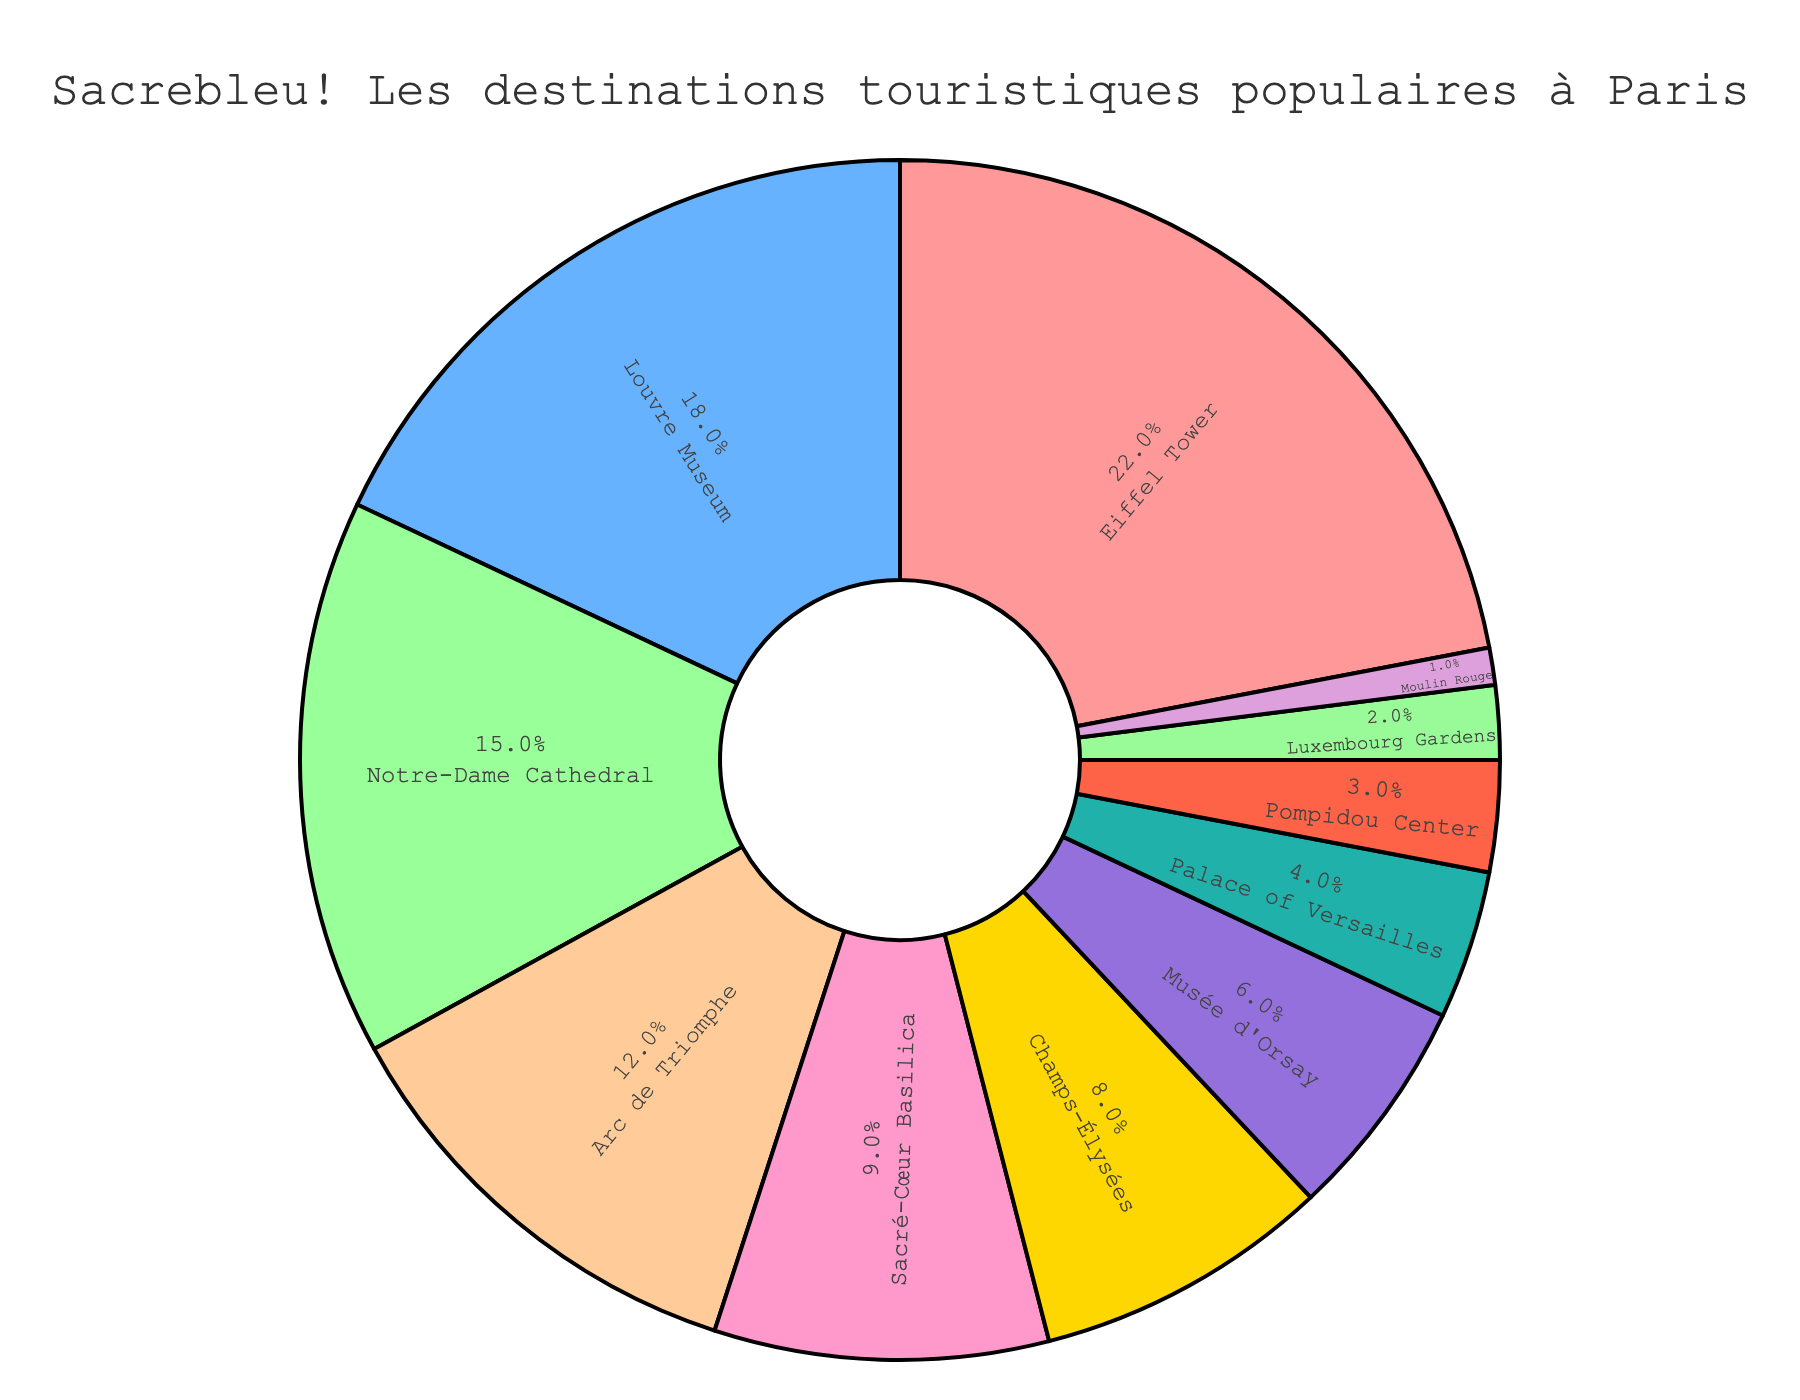Which tourist destination in Paris has the highest percentage of cab rides? The figure shows the breakdown of popular tourist destinations in Paris by percentage of cab rides. The Eiffel Tower has the largest segment in the pie chart, indicating it has the highest percentage.
Answer: Eiffel Tower What is the combined percentage of cab rides to the Louvre Museum and Notre-Dame Cathedral? According to the pie chart, the Louvre Museum accounts for 18% of cab rides, and the Notre-Dame Cathedral accounts for 15%. Adding these together gives us a combined percentage. 18% + 15% = 33%
Answer: 33% Which destination has a higher percentage of cab rides, Sacré-Cœur Basilica or Arc de Triomphe? By observing the pie chart, Sacré-Cœur Basilica has 9%, while Arc de Triomphe has 12%. Comparing these percentages, Arc de Triomphe has a higher percentage.
Answer: Arc de Triomphe What is the difference in percentage between the destination with the lowest cab rides and the destination with the highest cab rides? The destination with the highest percentage of cab rides is the Eiffel Tower at 22%, and the destination with the lowest percentage is Moulin Rouge at 1%. The difference is calculated by subtracting the smallest percentage from the largest percentage. 22% - 1% = 21%
Answer: 21% What color represents the Champs-Élysées in the pie chart? By observing the pie chart legend, each destination is represented by different colors. The Champs-Élysées is represented by the color that matches its segment in the pie chart. The color of the Champs-Élysées segment is yellow.
Answer: yellow How many more percentage points are there for Musée d'Orsay compared to Luxembourg Gardens? According to the pie chart, Musée d'Orsay has a percentage of 6% and Luxembourg Gardens has 2%. Subtract the percentage of Luxembourg Gardens from Musée d'Orsay to find the difference: 6% - 2% = 4%
Answer: 4% What is the sum of percentages for the top three tourist destinations in Paris by cab rides? The top three destinations by percentage are the Eiffel Tower, Louvre Museum, and Notre-Dame Cathedral. Adding their respective percentages together: 22% (Eiffel Tower) + 18% (Louvre Museum) + 15% (Notre-Dame Cathedral) = 55%
Answer: 55% Which has a higher percentage, the Palace of Versailles or the Pompidou Center? By checking the pie chart, the Palace of Versailles has 4% while the Pompidou Center has 3%. Comparing these figures, the Palace of Versailles has a higher percentage.
Answer: Palace of Versailles 